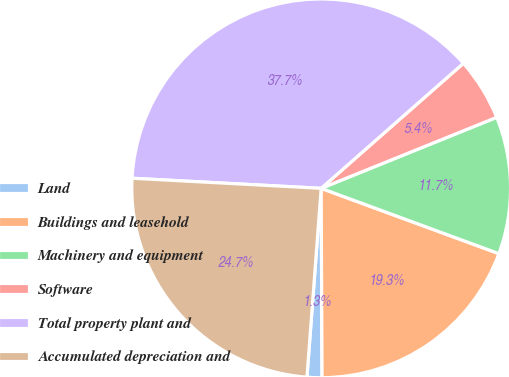Convert chart. <chart><loc_0><loc_0><loc_500><loc_500><pie_chart><fcel>Land<fcel>Buildings and leasehold<fcel>Machinery and equipment<fcel>Software<fcel>Total property plant and<fcel>Accumulated depreciation and<nl><fcel>1.27%<fcel>19.32%<fcel>11.72%<fcel>5.36%<fcel>37.67%<fcel>24.65%<nl></chart> 